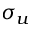Convert formula to latex. <formula><loc_0><loc_0><loc_500><loc_500>\sigma _ { u }</formula> 